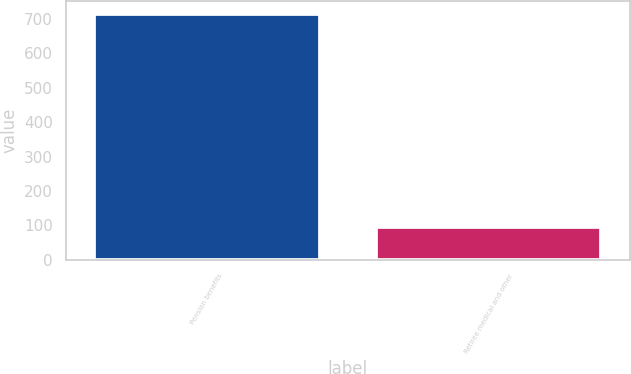Convert chart to OTSL. <chart><loc_0><loc_0><loc_500><loc_500><bar_chart><fcel>Pension benefits<fcel>Retiree medical and other<nl><fcel>715<fcel>96<nl></chart> 